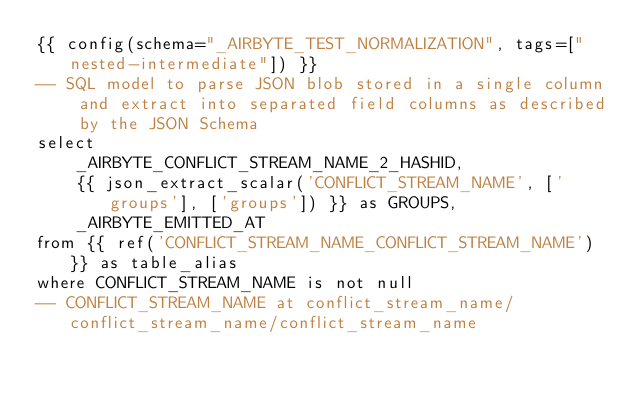Convert code to text. <code><loc_0><loc_0><loc_500><loc_500><_SQL_>{{ config(schema="_AIRBYTE_TEST_NORMALIZATION", tags=["nested-intermediate"]) }}
-- SQL model to parse JSON blob stored in a single column and extract into separated field columns as described by the JSON Schema
select
    _AIRBYTE_CONFLICT_STREAM_NAME_2_HASHID,
    {{ json_extract_scalar('CONFLICT_STREAM_NAME', ['groups'], ['groups']) }} as GROUPS,
    _AIRBYTE_EMITTED_AT
from {{ ref('CONFLICT_STREAM_NAME_CONFLICT_STREAM_NAME') }} as table_alias
where CONFLICT_STREAM_NAME is not null
-- CONFLICT_STREAM_NAME at conflict_stream_name/conflict_stream_name/conflict_stream_name

</code> 